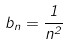Convert formula to latex. <formula><loc_0><loc_0><loc_500><loc_500>b _ { n } = \frac { 1 } { n ^ { 2 } }</formula> 